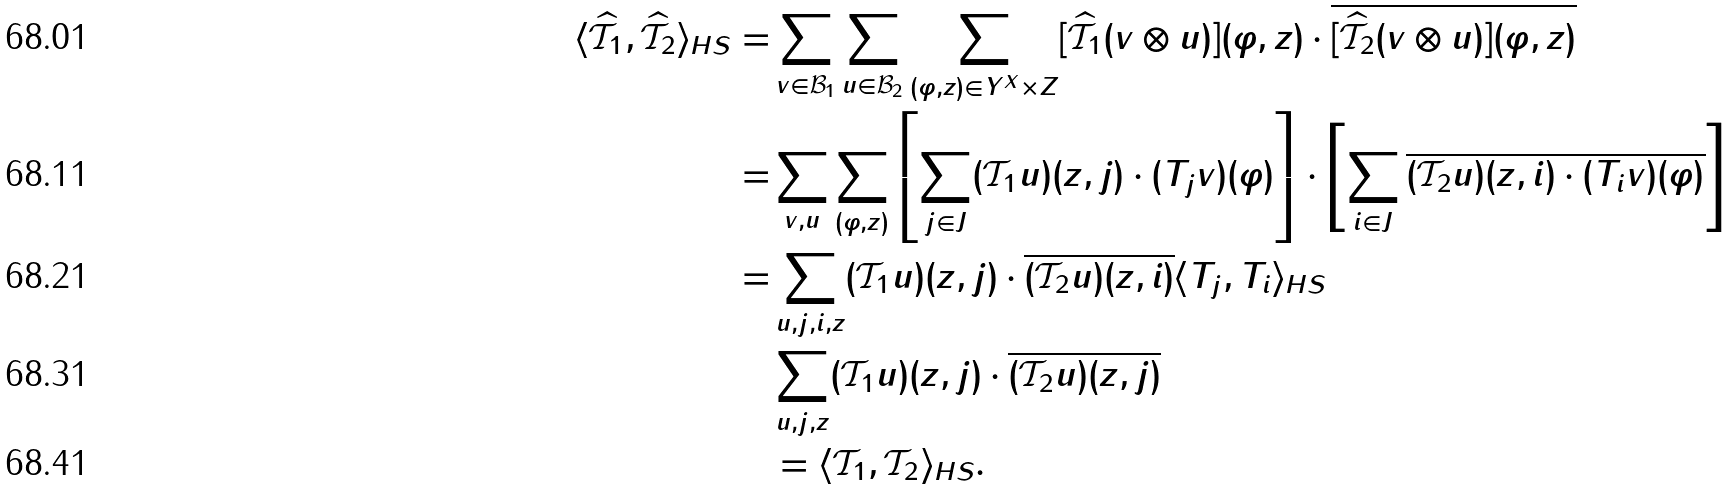<formula> <loc_0><loc_0><loc_500><loc_500>\langle \widehat { \mathcal { T } _ { 1 } } , \widehat { \mathcal { T } _ { 2 } } \rangle _ { H S } = & \sum _ { v \in \mathcal { B } _ { 1 } } \sum _ { u \in \mathcal { B } _ { 2 } } \sum _ { ( \varphi , z ) \in Y ^ { X } \times Z } [ \widehat { \mathcal { T } _ { 1 } } ( v \otimes u ) ] ( \varphi , z ) \cdot \overline { [ \widehat { \mathcal { T } _ { 2 } } ( v \otimes u ) ] ( \varphi , z ) } \\ = & \sum _ { v , u } \sum _ { ( \varphi , z ) } \left [ \sum _ { j \in J } ( \mathcal { T } _ { 1 } u ) ( z , j ) \cdot ( T _ { j } v ) ( \varphi ) \right ] \cdot \left [ \sum _ { i \in J } \overline { ( \mathcal { T } _ { 2 } u ) ( z , i ) \cdot ( T _ { i } v ) ( \varphi ) } \right ] \\ = & \sum _ { u , j , i , z } ( \mathcal { T } _ { 1 } u ) ( z , j ) \cdot \overline { ( \mathcal { T } _ { 2 } u ) ( z , i ) } \langle T _ { j } , T _ { i } \rangle _ { H S } \\ & \sum _ { u , j , z } ( \mathcal { T } _ { 1 } u ) ( z , j ) \cdot \overline { ( \mathcal { T } _ { 2 } u ) ( z , j ) } \\ & = \langle \mathcal { T } _ { 1 } , \mathcal { T } _ { 2 } \rangle _ { H S } .</formula> 